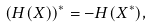<formula> <loc_0><loc_0><loc_500><loc_500>( H ( X ) ) ^ { * } = - H ( X ^ { * } ) ,</formula> 